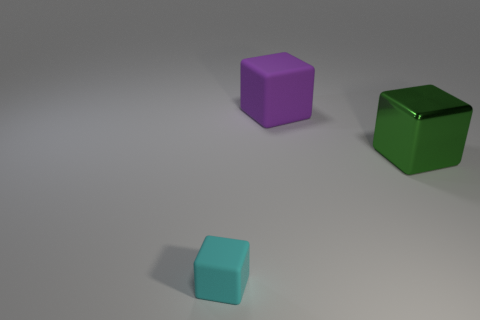Subtract all rubber cubes. How many cubes are left? 1 Add 2 large rubber things. How many objects exist? 5 Subtract all purple cubes. How many cubes are left? 2 Subtract 0 purple spheres. How many objects are left? 3 Subtract 1 blocks. How many blocks are left? 2 Subtract all cyan cubes. Subtract all blue cylinders. How many cubes are left? 2 Subtract all cyan spheres. How many brown blocks are left? 0 Subtract all rubber things. Subtract all purple matte objects. How many objects are left? 0 Add 1 green objects. How many green objects are left? 2 Add 3 metal things. How many metal things exist? 4 